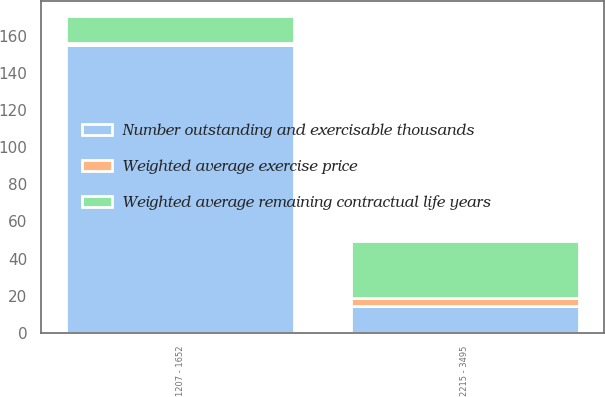Convert chart to OTSL. <chart><loc_0><loc_0><loc_500><loc_500><stacked_bar_chart><ecel><fcel>1207 - 1652<fcel>2215 - 3495<nl><fcel>Number outstanding and exercisable thousands<fcel>155<fcel>14.55<nl><fcel>Weighted average exercise price<fcel>1.1<fcel>4.3<nl><fcel>Weighted average remaining contractual life years<fcel>14.55<fcel>30.46<nl></chart> 